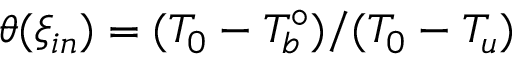Convert formula to latex. <formula><loc_0><loc_0><loc_500><loc_500>\theta ( { \xi _ { i n } } ) = ( T _ { 0 } - T _ { b } ^ { \circ } ) / ( T _ { 0 } - T _ { u } )</formula> 